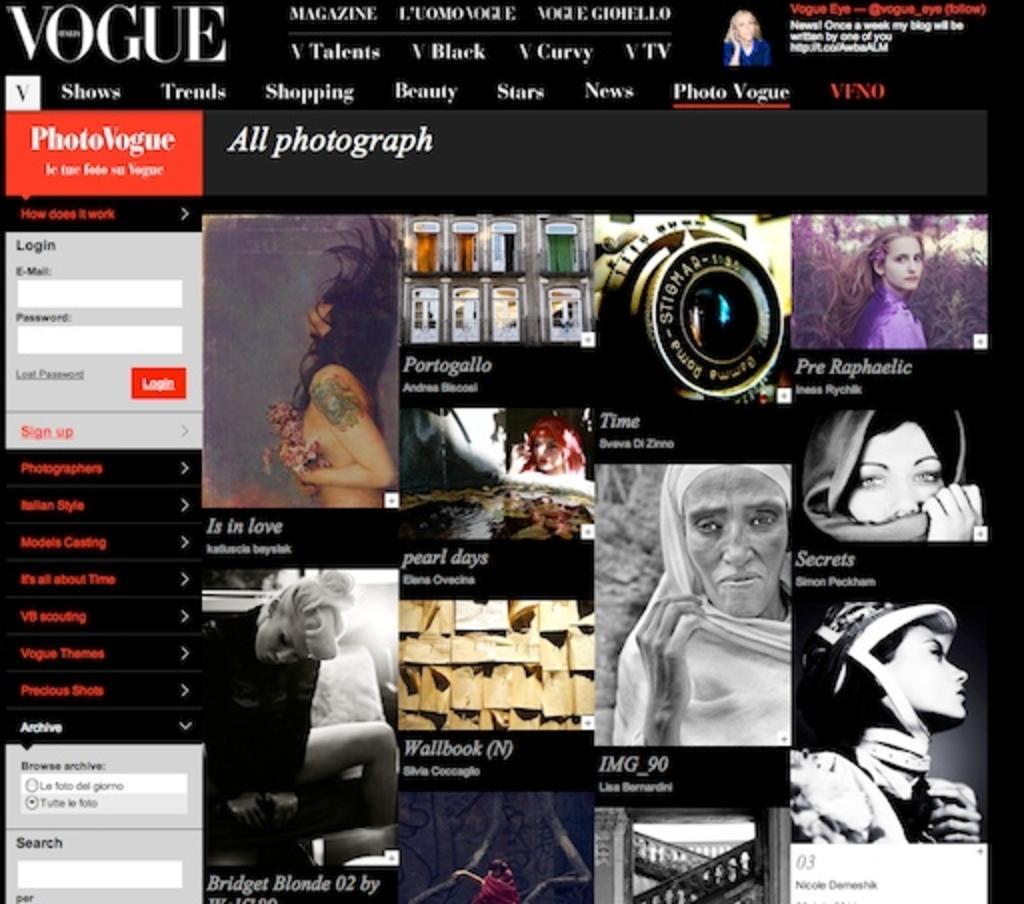Describe this image in one or two sentences. In this image there is the picture if the website, where we can see few people, ladder and some text. 